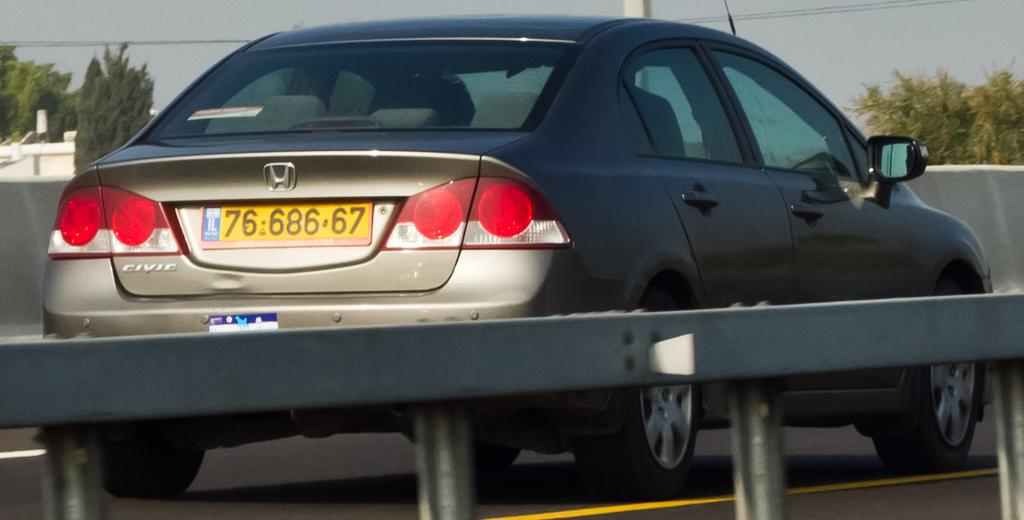<image>
Provide a brief description of the given image. A car has the model name Civic on the back of it. 